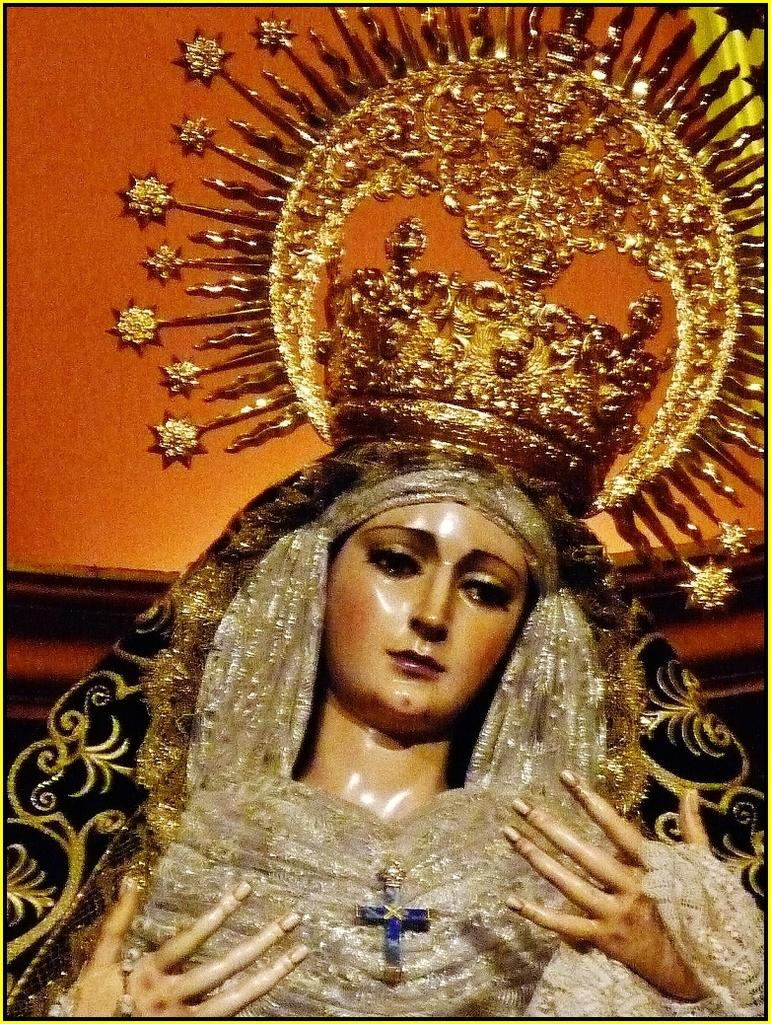What is the main subject of the image? There is a statue in the image. What is the statue wearing? The statue is wearing clothes and a crown. What color is the wall in the background of the image? The wall in the background of the image is orange. How many steps does the turkey take in the image? There is no turkey present in the image, so it is not possible to determine how many steps it might take. 